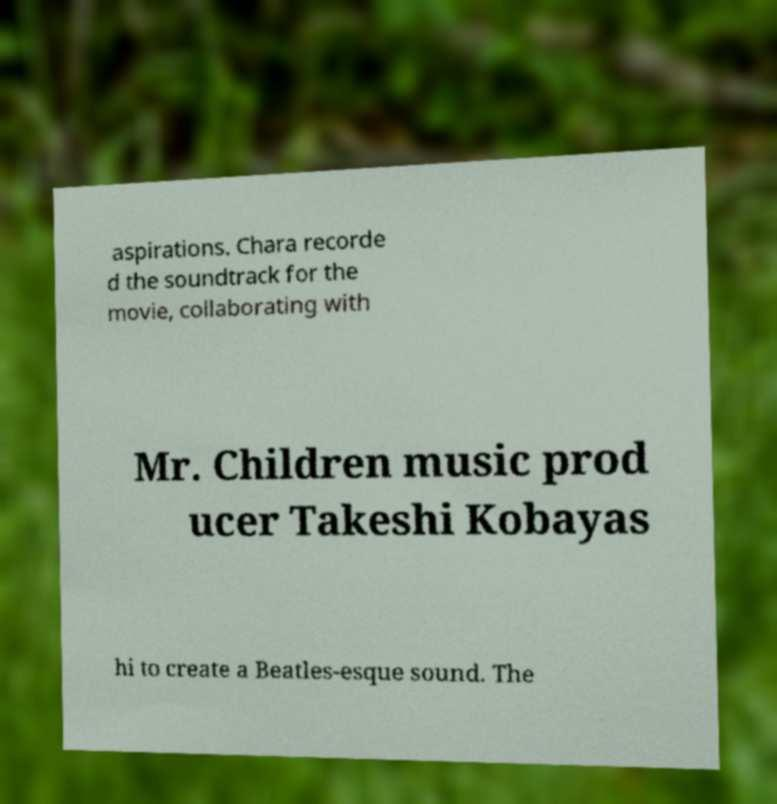What messages or text are displayed in this image? I need them in a readable, typed format. aspirations. Chara recorde d the soundtrack for the movie, collaborating with Mr. Children music prod ucer Takeshi Kobayas hi to create a Beatles-esque sound. The 